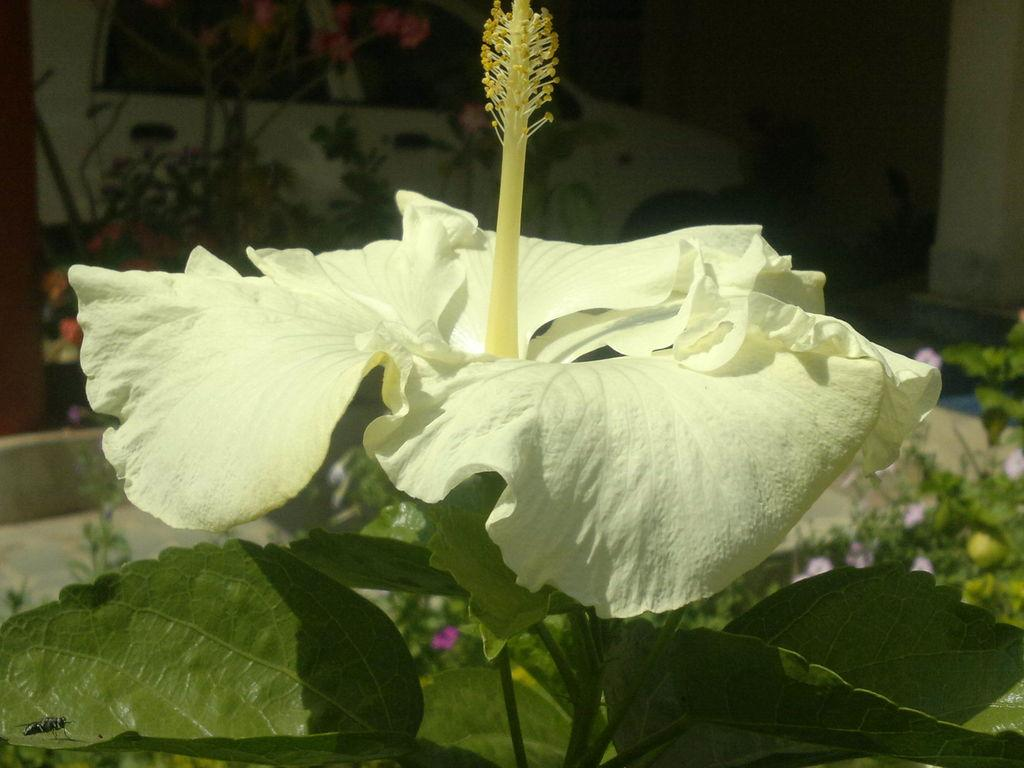What type of flower is on the plant in the image? There is a white hibiscus flower on a plant in the image. What can be seen in the background of the image? There are many flowering plants in the background. What is the color of the hibiscus flower? The hibiscus flower is white. Can you describe any other objects or vehicles in the image? Yes, there is a car in the image. What type of cake is being served on the channel in the image? There is no cake or channel present in the image; it features a white hibiscus flower on a plant and a car in the background. 